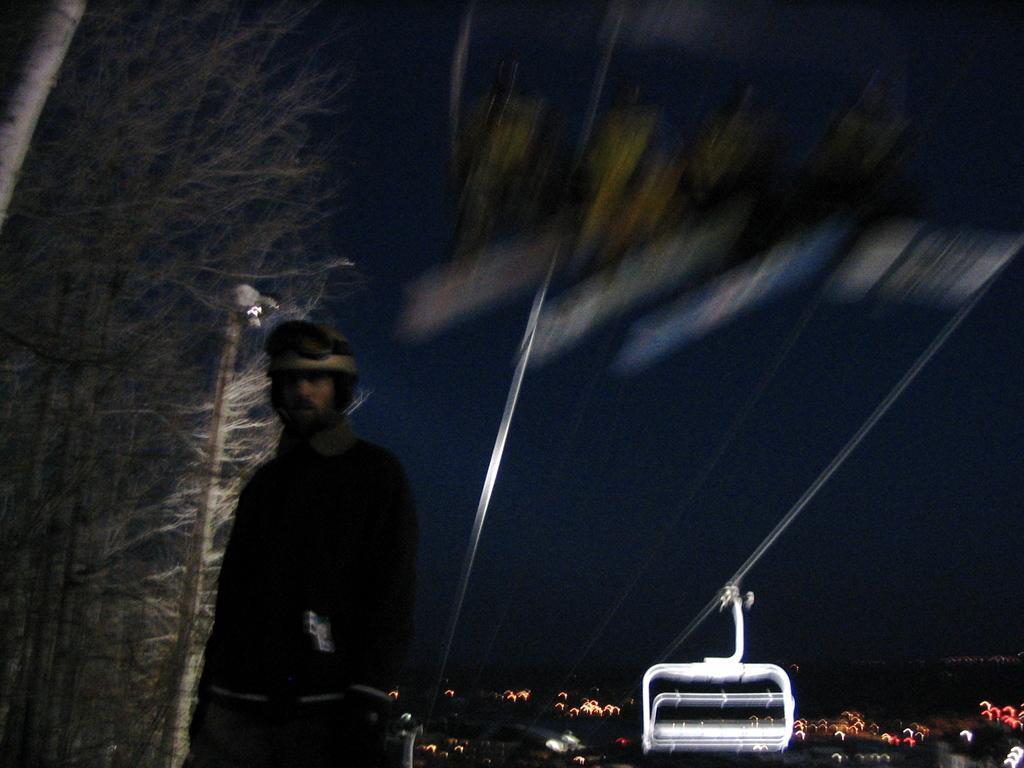How would you summarize this image in a sentence or two? In this image in the foreground there is one person who is standing, and there is one cable car and wires. In the background there are some buildings, lights and trees and poles. 